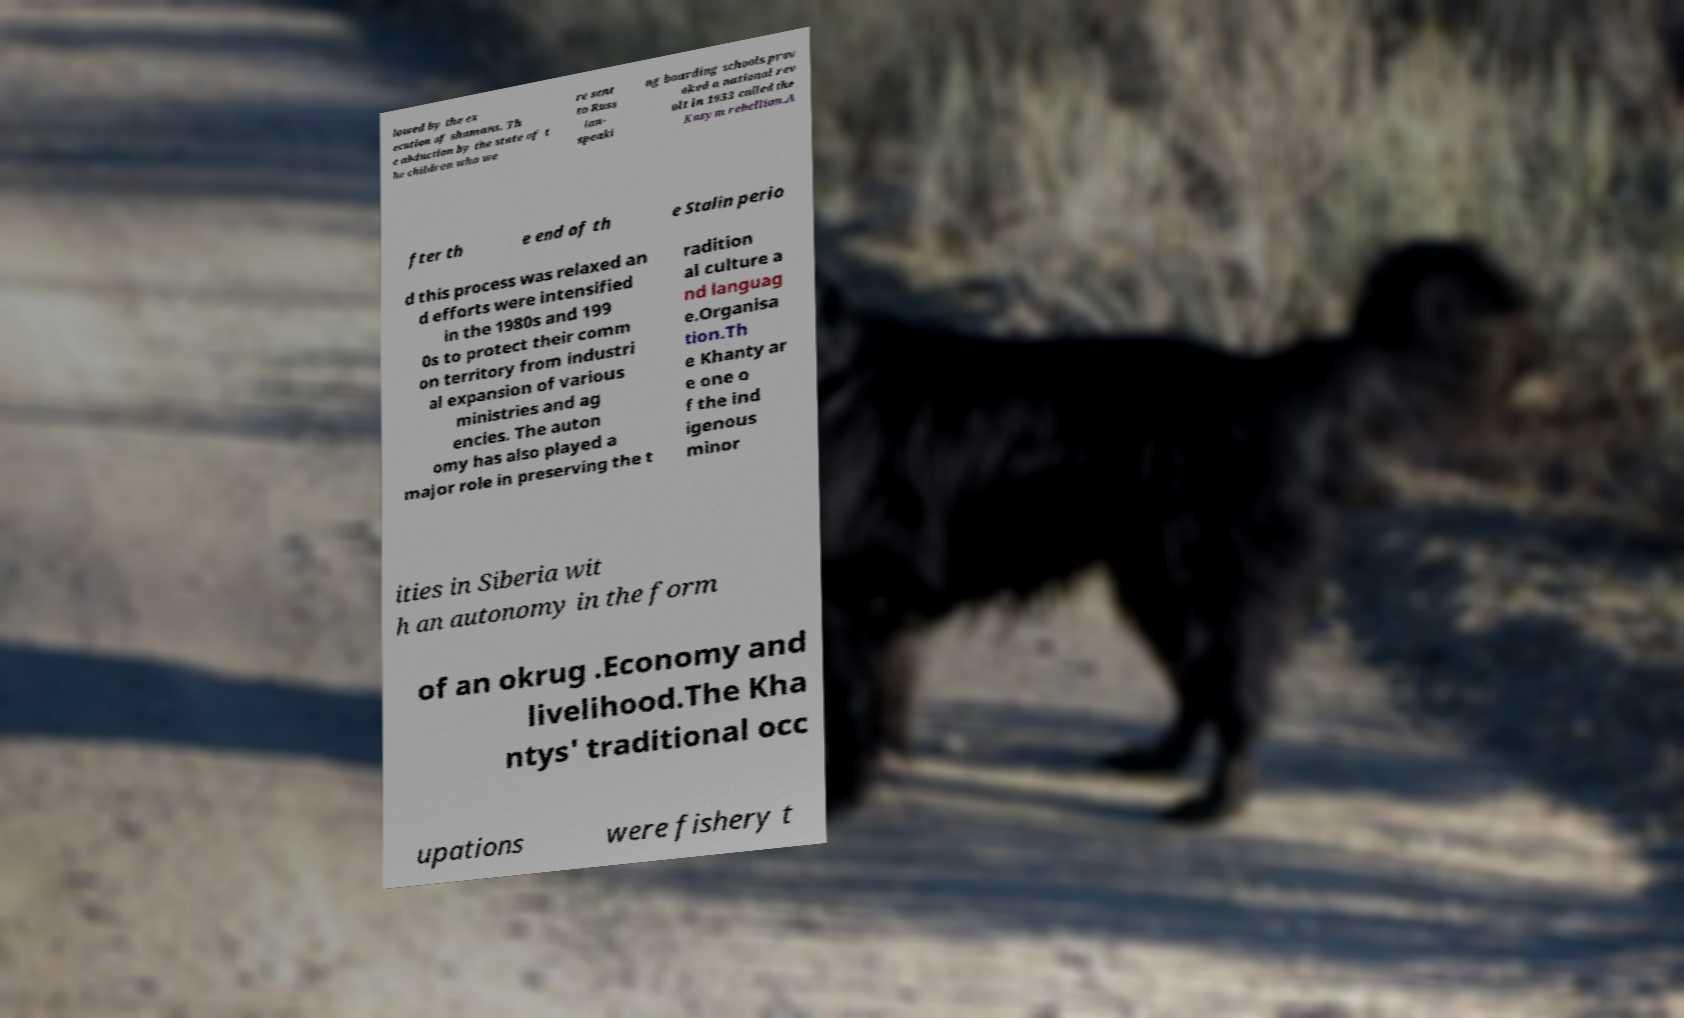For documentation purposes, I need the text within this image transcribed. Could you provide that? lowed by the ex ecution of shamans. Th e abduction by the state of t he children who we re sent to Russ ian- speaki ng boarding schools prov oked a national rev olt in 1933 called the Kazym rebellion.A fter th e end of th e Stalin perio d this process was relaxed an d efforts were intensified in the 1980s and 199 0s to protect their comm on territory from industri al expansion of various ministries and ag encies. The auton omy has also played a major role in preserving the t radition al culture a nd languag e.Organisa tion.Th e Khanty ar e one o f the ind igenous minor ities in Siberia wit h an autonomy in the form of an okrug .Economy and livelihood.The Kha ntys' traditional occ upations were fishery t 